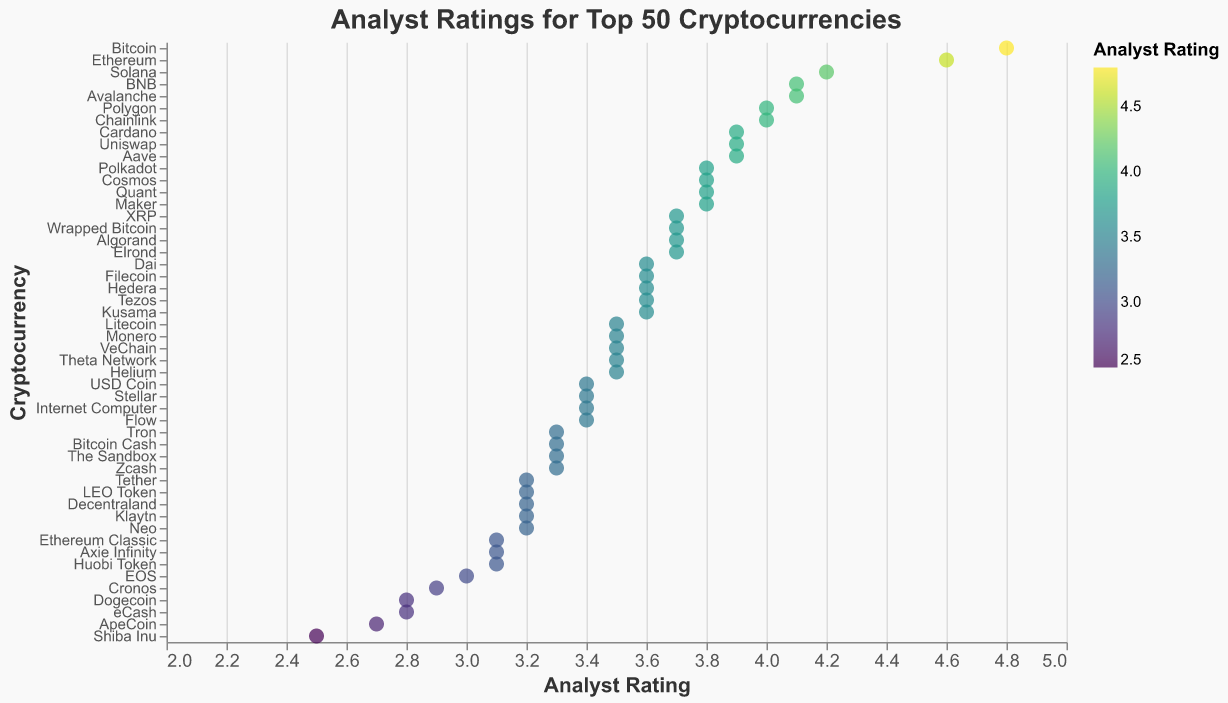Which cryptocurrency has the highest analyst rating? By observing the strip plot, we can identify the dot that is farthest to the right, indicating the highest analyst rating.
Answer: Bitcoin What's the lowest analyst rating given and to which cryptocurrency does it belong? Find the dot that is farthest to the left on the x-axis and check its corresponding y-axis.
Answer: 2.5, Shiba Inu What is the average analyst rating of Bitcoin, Ethereum, and Solana? Add the ratings of Bitcoin (4.8), Ethereum (4.6), and Solana (4.2), then divide by 3. (4.8 + 4.6 + 4.2) / 3 = 4.533.
Answer: 4.53 Which cryptocurrencies have an analyst rating greater than 4.0? Look for all dots positioned to the right of the point labeled 4.0 on the x-axis and identify their corresponding cryptocurrencies on the y-axis.
Answer: Bitcoin, Ethereum, Solana, BNB, Avalanche Compare the analyst rating of Dogecoin and Shiba Inu. Which one has a higher rating and by how much? Dogecoin has a rating of 2.8, and Shiba Inu has 2.5. The difference is 2.8 - 2.5 = 0.3.
Answer: Dogecoin by 0.3 How many cryptocurrencies have an analyst rating below 3.0? Count the number of dots that appear on the left of the 3.0 mark on the x-axis.
Answer: 4 What is the median analyst rating for all cryptocurrencies? To find the median, list all the analyst ratings in numerical order and find the middle value. With 50 cryptocurrencies, the median is the average of the 25th and 26th ratings. Look at the positional values surrounding the midpoint to determine this.
Answer: 3.6 What is the span of analyst ratings from the lowest to the highest? Subtract the lowest analyst rating (2.5) from the highest (4.8): 4.8 - 2.5 = 2.3.
Answer: 2.3 Which cryptocurrencies have exactly a 3.2 analyst rating? Locate the 3.2 mark on the x-axis and see which dots align with it on the y-axis.
Answer: Tether, LEO Token, Decentraland, Klaytn, Neo Has Solana been rated better than Cardano? Compare the positions of Solana and Cardano on the x-axis. Solana sits at 4.2, while Cardano is at 3.9.
Answer: Yes 